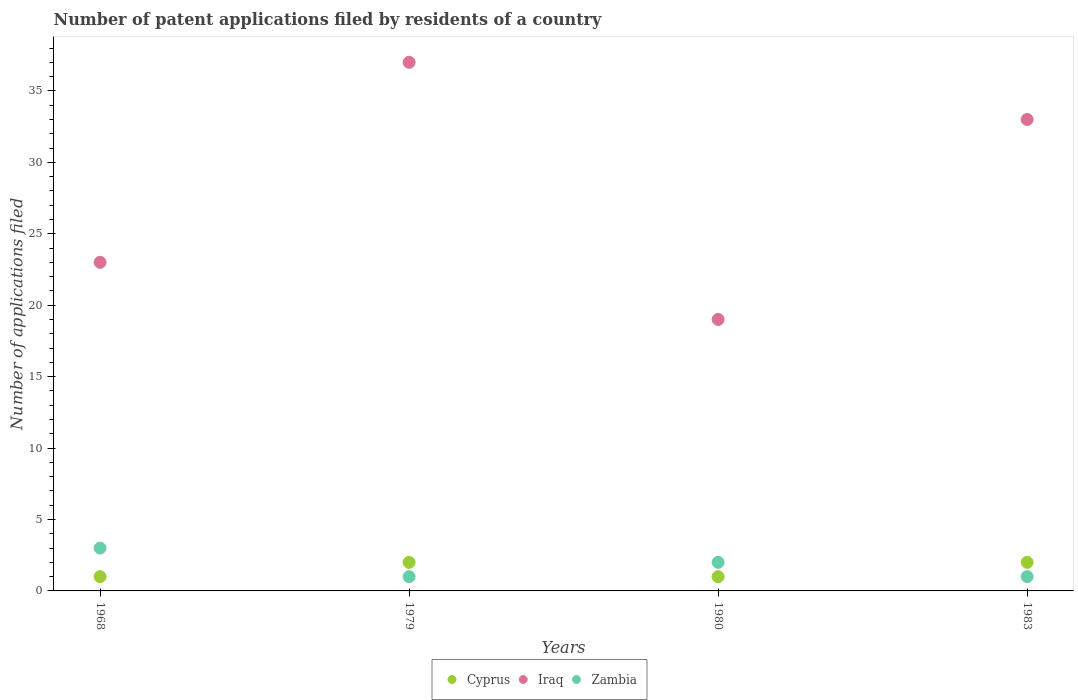Is the number of dotlines equal to the number of legend labels?
Your response must be concise. Yes. Across all years, what is the maximum number of applications filed in Cyprus?
Your answer should be compact. 2. Across all years, what is the minimum number of applications filed in Cyprus?
Provide a succinct answer. 1. In which year was the number of applications filed in Iraq maximum?
Give a very brief answer. 1979. In which year was the number of applications filed in Zambia minimum?
Your response must be concise. 1979. What is the total number of applications filed in Iraq in the graph?
Your answer should be compact. 112. In how many years, is the number of applications filed in Cyprus greater than 33?
Your response must be concise. 0. What is the ratio of the number of applications filed in Zambia in 1980 to that in 1983?
Ensure brevity in your answer.  2. Is the number of applications filed in Iraq in 1968 less than that in 1979?
Keep it short and to the point. Yes. In how many years, is the number of applications filed in Zambia greater than the average number of applications filed in Zambia taken over all years?
Ensure brevity in your answer.  2. Is the number of applications filed in Zambia strictly greater than the number of applications filed in Cyprus over the years?
Ensure brevity in your answer.  No. Is the number of applications filed in Cyprus strictly less than the number of applications filed in Zambia over the years?
Offer a terse response. No. How many dotlines are there?
Ensure brevity in your answer.  3. How many years are there in the graph?
Your answer should be compact. 4. What is the difference between two consecutive major ticks on the Y-axis?
Provide a short and direct response. 5. Does the graph contain any zero values?
Offer a terse response. No. How many legend labels are there?
Give a very brief answer. 3. What is the title of the graph?
Keep it short and to the point. Number of patent applications filed by residents of a country. Does "West Bank and Gaza" appear as one of the legend labels in the graph?
Ensure brevity in your answer.  No. What is the label or title of the X-axis?
Provide a short and direct response. Years. What is the label or title of the Y-axis?
Ensure brevity in your answer.  Number of applications filed. What is the Number of applications filed of Cyprus in 1968?
Ensure brevity in your answer.  1. What is the Number of applications filed in Iraq in 1968?
Offer a very short reply. 23. What is the Number of applications filed in Zambia in 1968?
Your response must be concise. 3. What is the Number of applications filed of Cyprus in 1979?
Your answer should be compact. 2. What is the Number of applications filed in Iraq in 1979?
Provide a short and direct response. 37. What is the Number of applications filed in Cyprus in 1980?
Provide a succinct answer. 1. What is the Number of applications filed of Iraq in 1983?
Offer a terse response. 33. What is the Number of applications filed of Zambia in 1983?
Give a very brief answer. 1. Across all years, what is the maximum Number of applications filed of Zambia?
Offer a terse response. 3. Across all years, what is the minimum Number of applications filed in Cyprus?
Your answer should be compact. 1. What is the total Number of applications filed of Cyprus in the graph?
Provide a short and direct response. 6. What is the total Number of applications filed in Iraq in the graph?
Give a very brief answer. 112. What is the total Number of applications filed in Zambia in the graph?
Ensure brevity in your answer.  7. What is the difference between the Number of applications filed of Cyprus in 1968 and that in 1980?
Your response must be concise. 0. What is the difference between the Number of applications filed of Zambia in 1968 and that in 1980?
Your answer should be very brief. 1. What is the difference between the Number of applications filed in Iraq in 1968 and that in 1983?
Give a very brief answer. -10. What is the difference between the Number of applications filed of Zambia in 1968 and that in 1983?
Offer a terse response. 2. What is the difference between the Number of applications filed in Cyprus in 1979 and that in 1980?
Your answer should be compact. 1. What is the difference between the Number of applications filed in Zambia in 1979 and that in 1980?
Make the answer very short. -1. What is the difference between the Number of applications filed of Cyprus in 1979 and that in 1983?
Offer a very short reply. 0. What is the difference between the Number of applications filed in Cyprus in 1980 and that in 1983?
Offer a terse response. -1. What is the difference between the Number of applications filed in Iraq in 1980 and that in 1983?
Keep it short and to the point. -14. What is the difference between the Number of applications filed in Zambia in 1980 and that in 1983?
Provide a succinct answer. 1. What is the difference between the Number of applications filed in Cyprus in 1968 and the Number of applications filed in Iraq in 1979?
Give a very brief answer. -36. What is the difference between the Number of applications filed in Iraq in 1968 and the Number of applications filed in Zambia in 1979?
Your answer should be compact. 22. What is the difference between the Number of applications filed of Cyprus in 1968 and the Number of applications filed of Zambia in 1980?
Ensure brevity in your answer.  -1. What is the difference between the Number of applications filed in Cyprus in 1968 and the Number of applications filed in Iraq in 1983?
Give a very brief answer. -32. What is the difference between the Number of applications filed in Iraq in 1968 and the Number of applications filed in Zambia in 1983?
Make the answer very short. 22. What is the difference between the Number of applications filed of Cyprus in 1979 and the Number of applications filed of Iraq in 1980?
Offer a very short reply. -17. What is the difference between the Number of applications filed of Cyprus in 1979 and the Number of applications filed of Iraq in 1983?
Give a very brief answer. -31. What is the difference between the Number of applications filed of Cyprus in 1979 and the Number of applications filed of Zambia in 1983?
Provide a short and direct response. 1. What is the difference between the Number of applications filed in Cyprus in 1980 and the Number of applications filed in Iraq in 1983?
Offer a terse response. -32. What is the difference between the Number of applications filed of Cyprus in 1980 and the Number of applications filed of Zambia in 1983?
Keep it short and to the point. 0. What is the average Number of applications filed in Cyprus per year?
Ensure brevity in your answer.  1.5. What is the average Number of applications filed in Zambia per year?
Provide a succinct answer. 1.75. In the year 1968, what is the difference between the Number of applications filed of Cyprus and Number of applications filed of Iraq?
Provide a short and direct response. -22. In the year 1968, what is the difference between the Number of applications filed in Cyprus and Number of applications filed in Zambia?
Keep it short and to the point. -2. In the year 1979, what is the difference between the Number of applications filed in Cyprus and Number of applications filed in Iraq?
Keep it short and to the point. -35. In the year 1979, what is the difference between the Number of applications filed in Cyprus and Number of applications filed in Zambia?
Offer a very short reply. 1. In the year 1980, what is the difference between the Number of applications filed of Cyprus and Number of applications filed of Iraq?
Provide a short and direct response. -18. In the year 1980, what is the difference between the Number of applications filed in Cyprus and Number of applications filed in Zambia?
Offer a terse response. -1. In the year 1983, what is the difference between the Number of applications filed of Cyprus and Number of applications filed of Iraq?
Provide a succinct answer. -31. In the year 1983, what is the difference between the Number of applications filed in Cyprus and Number of applications filed in Zambia?
Keep it short and to the point. 1. In the year 1983, what is the difference between the Number of applications filed in Iraq and Number of applications filed in Zambia?
Your response must be concise. 32. What is the ratio of the Number of applications filed in Iraq in 1968 to that in 1979?
Give a very brief answer. 0.62. What is the ratio of the Number of applications filed of Cyprus in 1968 to that in 1980?
Your answer should be very brief. 1. What is the ratio of the Number of applications filed of Iraq in 1968 to that in 1980?
Provide a short and direct response. 1.21. What is the ratio of the Number of applications filed in Cyprus in 1968 to that in 1983?
Provide a short and direct response. 0.5. What is the ratio of the Number of applications filed in Iraq in 1968 to that in 1983?
Keep it short and to the point. 0.7. What is the ratio of the Number of applications filed of Cyprus in 1979 to that in 1980?
Give a very brief answer. 2. What is the ratio of the Number of applications filed in Iraq in 1979 to that in 1980?
Provide a short and direct response. 1.95. What is the ratio of the Number of applications filed of Zambia in 1979 to that in 1980?
Ensure brevity in your answer.  0.5. What is the ratio of the Number of applications filed in Iraq in 1979 to that in 1983?
Ensure brevity in your answer.  1.12. What is the ratio of the Number of applications filed of Zambia in 1979 to that in 1983?
Your answer should be very brief. 1. What is the ratio of the Number of applications filed of Cyprus in 1980 to that in 1983?
Give a very brief answer. 0.5. What is the ratio of the Number of applications filed of Iraq in 1980 to that in 1983?
Provide a succinct answer. 0.58. What is the difference between the highest and the second highest Number of applications filed of Cyprus?
Provide a succinct answer. 0. What is the difference between the highest and the lowest Number of applications filed of Iraq?
Give a very brief answer. 18. 